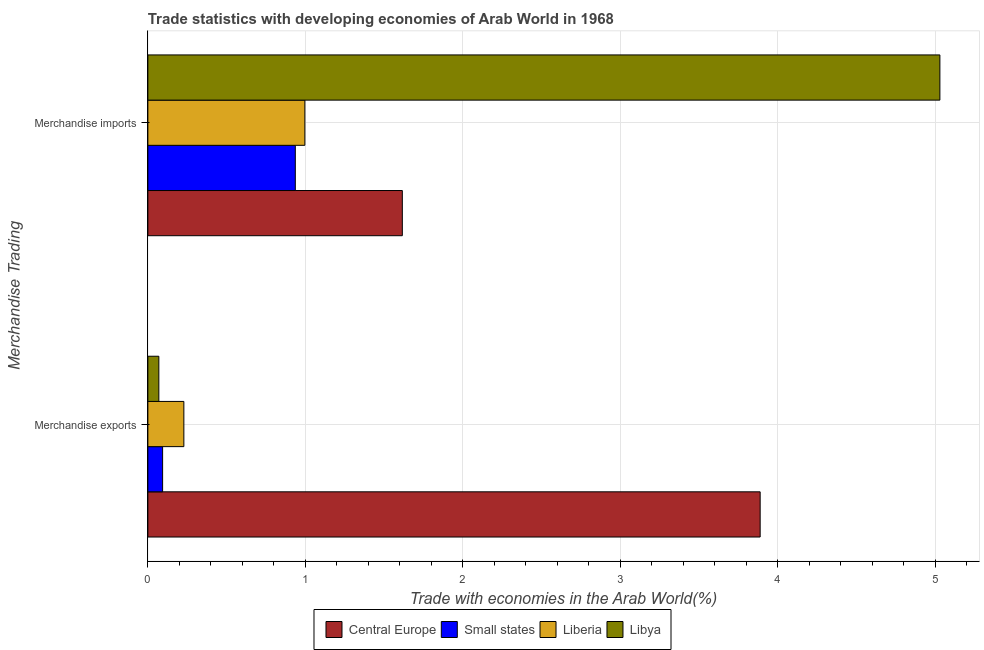How many different coloured bars are there?
Your answer should be very brief. 4. How many groups of bars are there?
Your answer should be compact. 2. Are the number of bars per tick equal to the number of legend labels?
Give a very brief answer. Yes. How many bars are there on the 1st tick from the bottom?
Offer a very short reply. 4. What is the label of the 2nd group of bars from the top?
Offer a terse response. Merchandise exports. What is the merchandise exports in Libya?
Provide a short and direct response. 0.07. Across all countries, what is the maximum merchandise exports?
Your answer should be very brief. 3.89. Across all countries, what is the minimum merchandise exports?
Offer a terse response. 0.07. In which country was the merchandise imports maximum?
Your answer should be compact. Libya. In which country was the merchandise exports minimum?
Provide a short and direct response. Libya. What is the total merchandise exports in the graph?
Your answer should be compact. 4.28. What is the difference between the merchandise imports in Liberia and that in Central Europe?
Offer a very short reply. -0.62. What is the difference between the merchandise exports in Libya and the merchandise imports in Small states?
Ensure brevity in your answer.  -0.87. What is the average merchandise imports per country?
Make the answer very short. 2.14. What is the difference between the merchandise exports and merchandise imports in Liberia?
Provide a short and direct response. -0.77. What is the ratio of the merchandise imports in Central Europe to that in Liberia?
Give a very brief answer. 1.62. In how many countries, is the merchandise imports greater than the average merchandise imports taken over all countries?
Offer a terse response. 1. What does the 1st bar from the top in Merchandise exports represents?
Ensure brevity in your answer.  Libya. What does the 1st bar from the bottom in Merchandise imports represents?
Provide a succinct answer. Central Europe. How many bars are there?
Provide a short and direct response. 8. Are the values on the major ticks of X-axis written in scientific E-notation?
Provide a short and direct response. No. Does the graph contain grids?
Keep it short and to the point. Yes. How many legend labels are there?
Your answer should be compact. 4. What is the title of the graph?
Provide a short and direct response. Trade statistics with developing economies of Arab World in 1968. What is the label or title of the X-axis?
Your answer should be compact. Trade with economies in the Arab World(%). What is the label or title of the Y-axis?
Ensure brevity in your answer.  Merchandise Trading. What is the Trade with economies in the Arab World(%) of Central Europe in Merchandise exports?
Give a very brief answer. 3.89. What is the Trade with economies in the Arab World(%) of Small states in Merchandise exports?
Offer a very short reply. 0.09. What is the Trade with economies in the Arab World(%) of Liberia in Merchandise exports?
Ensure brevity in your answer.  0.23. What is the Trade with economies in the Arab World(%) in Libya in Merchandise exports?
Your answer should be very brief. 0.07. What is the Trade with economies in the Arab World(%) of Central Europe in Merchandise imports?
Keep it short and to the point. 1.62. What is the Trade with economies in the Arab World(%) of Small states in Merchandise imports?
Provide a short and direct response. 0.94. What is the Trade with economies in the Arab World(%) in Liberia in Merchandise imports?
Provide a short and direct response. 1. What is the Trade with economies in the Arab World(%) in Libya in Merchandise imports?
Provide a short and direct response. 5.03. Across all Merchandise Trading, what is the maximum Trade with economies in the Arab World(%) in Central Europe?
Make the answer very short. 3.89. Across all Merchandise Trading, what is the maximum Trade with economies in the Arab World(%) in Small states?
Provide a short and direct response. 0.94. Across all Merchandise Trading, what is the maximum Trade with economies in the Arab World(%) of Liberia?
Provide a succinct answer. 1. Across all Merchandise Trading, what is the maximum Trade with economies in the Arab World(%) in Libya?
Provide a short and direct response. 5.03. Across all Merchandise Trading, what is the minimum Trade with economies in the Arab World(%) in Central Europe?
Make the answer very short. 1.62. Across all Merchandise Trading, what is the minimum Trade with economies in the Arab World(%) in Small states?
Provide a short and direct response. 0.09. Across all Merchandise Trading, what is the minimum Trade with economies in the Arab World(%) of Liberia?
Provide a succinct answer. 0.23. Across all Merchandise Trading, what is the minimum Trade with economies in the Arab World(%) of Libya?
Offer a very short reply. 0.07. What is the total Trade with economies in the Arab World(%) of Central Europe in the graph?
Ensure brevity in your answer.  5.5. What is the total Trade with economies in the Arab World(%) of Small states in the graph?
Make the answer very short. 1.03. What is the total Trade with economies in the Arab World(%) of Liberia in the graph?
Offer a very short reply. 1.23. What is the total Trade with economies in the Arab World(%) in Libya in the graph?
Ensure brevity in your answer.  5.1. What is the difference between the Trade with economies in the Arab World(%) of Central Europe in Merchandise exports and that in Merchandise imports?
Your response must be concise. 2.27. What is the difference between the Trade with economies in the Arab World(%) in Small states in Merchandise exports and that in Merchandise imports?
Provide a succinct answer. -0.84. What is the difference between the Trade with economies in the Arab World(%) in Liberia in Merchandise exports and that in Merchandise imports?
Provide a succinct answer. -0.77. What is the difference between the Trade with economies in the Arab World(%) in Libya in Merchandise exports and that in Merchandise imports?
Offer a terse response. -4.96. What is the difference between the Trade with economies in the Arab World(%) of Central Europe in Merchandise exports and the Trade with economies in the Arab World(%) of Small states in Merchandise imports?
Ensure brevity in your answer.  2.95. What is the difference between the Trade with economies in the Arab World(%) in Central Europe in Merchandise exports and the Trade with economies in the Arab World(%) in Liberia in Merchandise imports?
Your response must be concise. 2.89. What is the difference between the Trade with economies in the Arab World(%) of Central Europe in Merchandise exports and the Trade with economies in the Arab World(%) of Libya in Merchandise imports?
Provide a succinct answer. -1.14. What is the difference between the Trade with economies in the Arab World(%) in Small states in Merchandise exports and the Trade with economies in the Arab World(%) in Liberia in Merchandise imports?
Make the answer very short. -0.9. What is the difference between the Trade with economies in the Arab World(%) of Small states in Merchandise exports and the Trade with economies in the Arab World(%) of Libya in Merchandise imports?
Make the answer very short. -4.93. What is the difference between the Trade with economies in the Arab World(%) of Liberia in Merchandise exports and the Trade with economies in the Arab World(%) of Libya in Merchandise imports?
Provide a succinct answer. -4.8. What is the average Trade with economies in the Arab World(%) in Central Europe per Merchandise Trading?
Offer a terse response. 2.75. What is the average Trade with economies in the Arab World(%) in Small states per Merchandise Trading?
Ensure brevity in your answer.  0.51. What is the average Trade with economies in the Arab World(%) in Liberia per Merchandise Trading?
Make the answer very short. 0.61. What is the average Trade with economies in the Arab World(%) of Libya per Merchandise Trading?
Make the answer very short. 2.55. What is the difference between the Trade with economies in the Arab World(%) of Central Europe and Trade with economies in the Arab World(%) of Small states in Merchandise exports?
Your answer should be very brief. 3.79. What is the difference between the Trade with economies in the Arab World(%) in Central Europe and Trade with economies in the Arab World(%) in Liberia in Merchandise exports?
Give a very brief answer. 3.66. What is the difference between the Trade with economies in the Arab World(%) in Central Europe and Trade with economies in the Arab World(%) in Libya in Merchandise exports?
Offer a terse response. 3.82. What is the difference between the Trade with economies in the Arab World(%) in Small states and Trade with economies in the Arab World(%) in Liberia in Merchandise exports?
Offer a very short reply. -0.13. What is the difference between the Trade with economies in the Arab World(%) of Small states and Trade with economies in the Arab World(%) of Libya in Merchandise exports?
Offer a terse response. 0.02. What is the difference between the Trade with economies in the Arab World(%) of Liberia and Trade with economies in the Arab World(%) of Libya in Merchandise exports?
Offer a very short reply. 0.16. What is the difference between the Trade with economies in the Arab World(%) of Central Europe and Trade with economies in the Arab World(%) of Small states in Merchandise imports?
Provide a succinct answer. 0.68. What is the difference between the Trade with economies in the Arab World(%) of Central Europe and Trade with economies in the Arab World(%) of Liberia in Merchandise imports?
Your response must be concise. 0.62. What is the difference between the Trade with economies in the Arab World(%) of Central Europe and Trade with economies in the Arab World(%) of Libya in Merchandise imports?
Offer a terse response. -3.41. What is the difference between the Trade with economies in the Arab World(%) in Small states and Trade with economies in the Arab World(%) in Liberia in Merchandise imports?
Make the answer very short. -0.06. What is the difference between the Trade with economies in the Arab World(%) of Small states and Trade with economies in the Arab World(%) of Libya in Merchandise imports?
Keep it short and to the point. -4.09. What is the difference between the Trade with economies in the Arab World(%) in Liberia and Trade with economies in the Arab World(%) in Libya in Merchandise imports?
Offer a very short reply. -4.03. What is the ratio of the Trade with economies in the Arab World(%) in Central Europe in Merchandise exports to that in Merchandise imports?
Offer a very short reply. 2.41. What is the ratio of the Trade with economies in the Arab World(%) of Small states in Merchandise exports to that in Merchandise imports?
Make the answer very short. 0.1. What is the ratio of the Trade with economies in the Arab World(%) of Liberia in Merchandise exports to that in Merchandise imports?
Offer a very short reply. 0.23. What is the ratio of the Trade with economies in the Arab World(%) of Libya in Merchandise exports to that in Merchandise imports?
Your response must be concise. 0.01. What is the difference between the highest and the second highest Trade with economies in the Arab World(%) in Central Europe?
Make the answer very short. 2.27. What is the difference between the highest and the second highest Trade with economies in the Arab World(%) of Small states?
Offer a very short reply. 0.84. What is the difference between the highest and the second highest Trade with economies in the Arab World(%) in Liberia?
Make the answer very short. 0.77. What is the difference between the highest and the second highest Trade with economies in the Arab World(%) of Libya?
Provide a short and direct response. 4.96. What is the difference between the highest and the lowest Trade with economies in the Arab World(%) in Central Europe?
Give a very brief answer. 2.27. What is the difference between the highest and the lowest Trade with economies in the Arab World(%) of Small states?
Give a very brief answer. 0.84. What is the difference between the highest and the lowest Trade with economies in the Arab World(%) in Liberia?
Give a very brief answer. 0.77. What is the difference between the highest and the lowest Trade with economies in the Arab World(%) of Libya?
Your response must be concise. 4.96. 